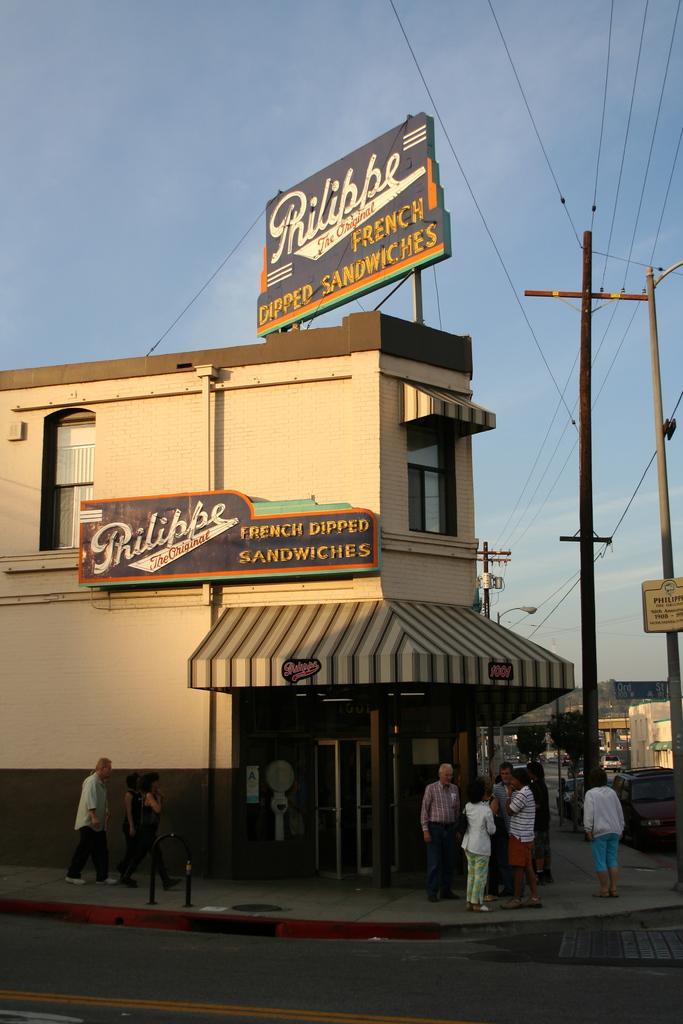In one or two sentences, can you explain what this image depicts? In this image there is a road at the bottom. Behind the road there is a footpath. On the footpath there is a sandwich store under the building. At the top of the building there is a big hoarding. On the right side there are electric poles on the footpath. 